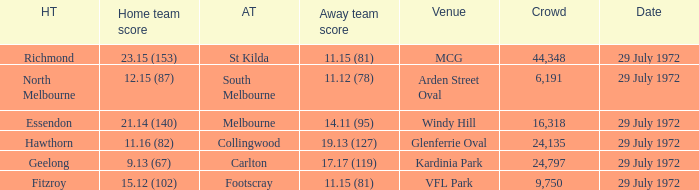When was the footscray away team's 11.15 (81) score recorded? 29 July 1972. 